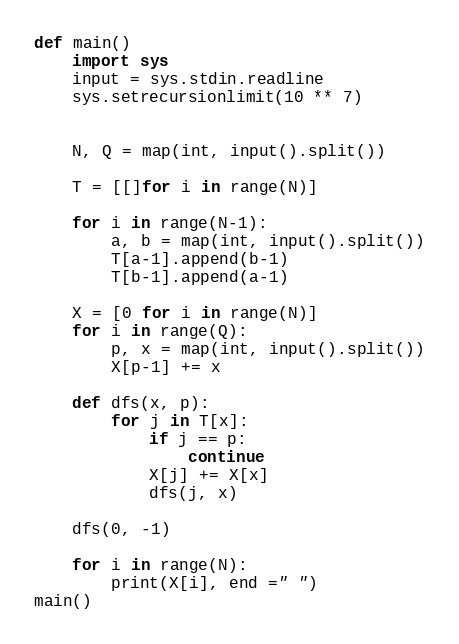Convert code to text. <code><loc_0><loc_0><loc_500><loc_500><_Python_>def main()
	import sys
	input = sys.stdin.readline
	sys.setrecursionlimit(10 ** 7)
 
 
	N, Q = map(int, input().split())
 
	T = [[]for i in range(N)]
 
	for i in range(N-1):
    	a, b = map(int, input().split())
    	T[a-1].append(b-1)
    	T[b-1].append(a-1)
 
	X = [0 for i in range(N)]
	for i in range(Q):
    	p, x = map(int, input().split())
    	X[p-1] += x
 
	def dfs(x, p):
    	for j in T[x]:
        	if j == p:
            	continue
        	X[j] += X[x]
        	dfs(j, x)
 
	dfs(0, -1)
 
	for i in range(N):
    	print(X[i], end =" ")
main()</code> 